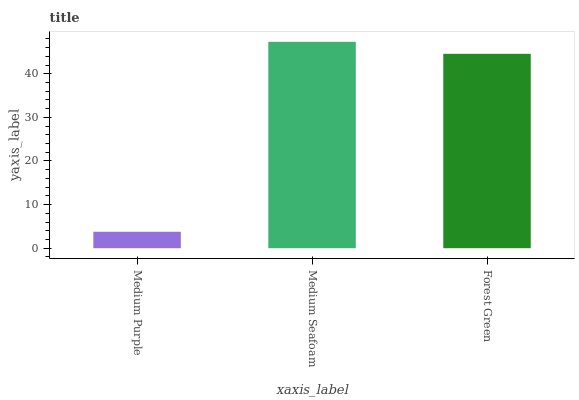Is Medium Purple the minimum?
Answer yes or no. Yes. Is Medium Seafoam the maximum?
Answer yes or no. Yes. Is Forest Green the minimum?
Answer yes or no. No. Is Forest Green the maximum?
Answer yes or no. No. Is Medium Seafoam greater than Forest Green?
Answer yes or no. Yes. Is Forest Green less than Medium Seafoam?
Answer yes or no. Yes. Is Forest Green greater than Medium Seafoam?
Answer yes or no. No. Is Medium Seafoam less than Forest Green?
Answer yes or no. No. Is Forest Green the high median?
Answer yes or no. Yes. Is Forest Green the low median?
Answer yes or no. Yes. Is Medium Seafoam the high median?
Answer yes or no. No. Is Medium Purple the low median?
Answer yes or no. No. 